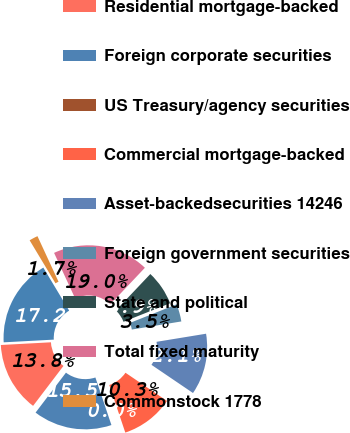Convert chart to OTSL. <chart><loc_0><loc_0><loc_500><loc_500><pie_chart><fcel>UScorporatesecurities 72211<fcel>Residential mortgage-backed<fcel>Foreign corporate securities<fcel>US Treasury/agency securities<fcel>Commercial mortgage-backed<fcel>Asset-backedsecurities 14246<fcel>Foreign government securities<fcel>State and political<fcel>Total fixed maturity<fcel>Commonstock 1778<nl><fcel>17.24%<fcel>13.79%<fcel>15.52%<fcel>0.0%<fcel>10.34%<fcel>12.07%<fcel>3.45%<fcel>6.9%<fcel>18.96%<fcel>1.72%<nl></chart> 